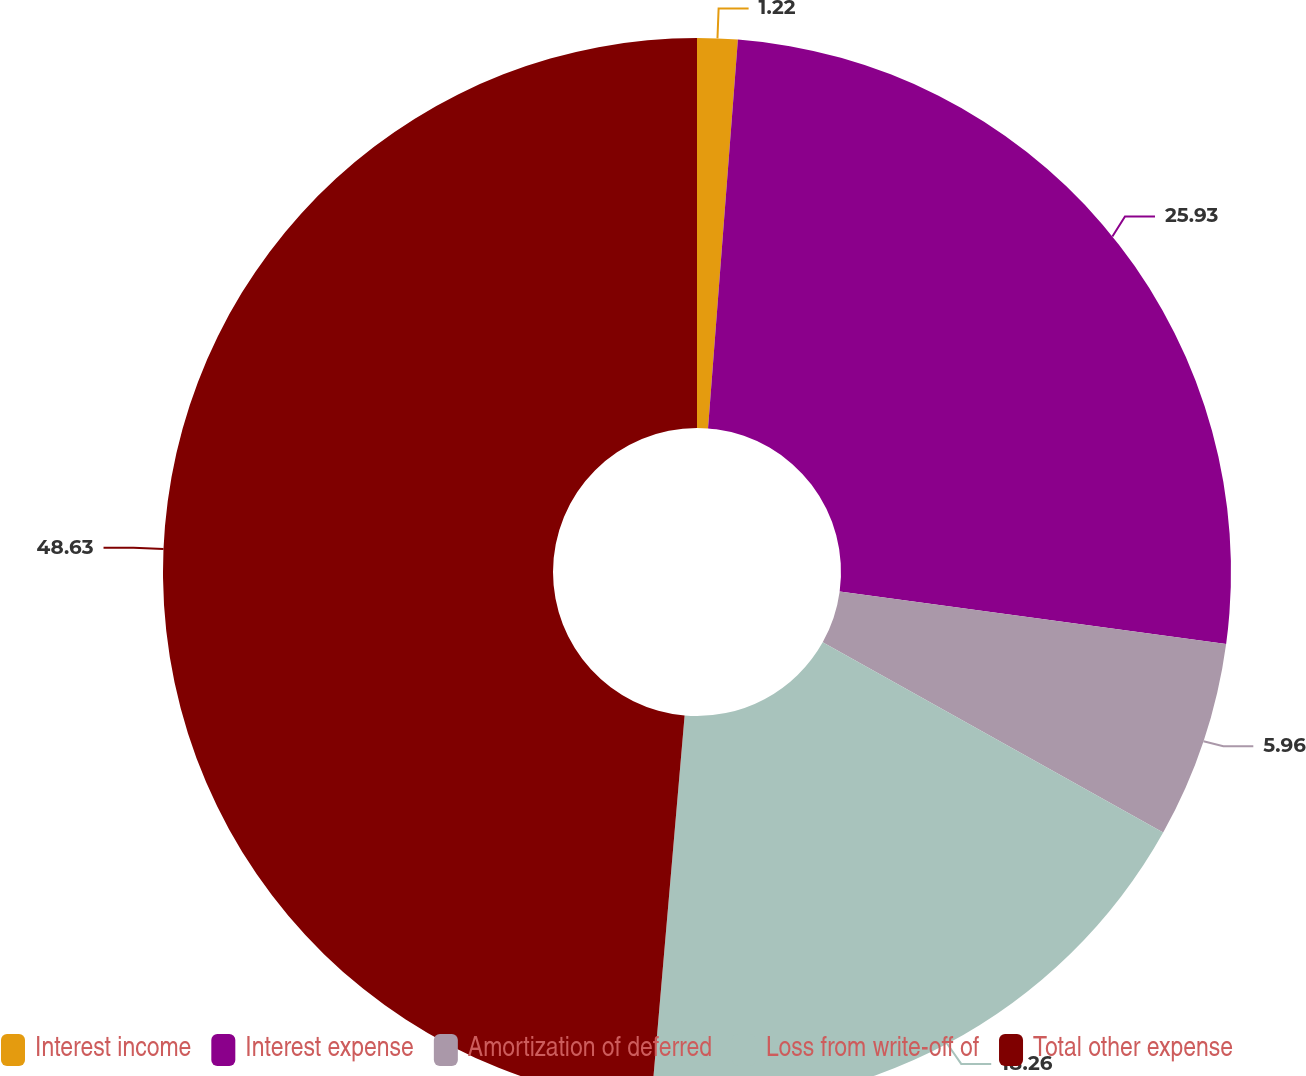<chart> <loc_0><loc_0><loc_500><loc_500><pie_chart><fcel>Interest income<fcel>Interest expense<fcel>Amortization of deferred<fcel>Loss from write-off of<fcel>Total other expense<nl><fcel>1.22%<fcel>25.93%<fcel>5.96%<fcel>18.26%<fcel>48.63%<nl></chart> 